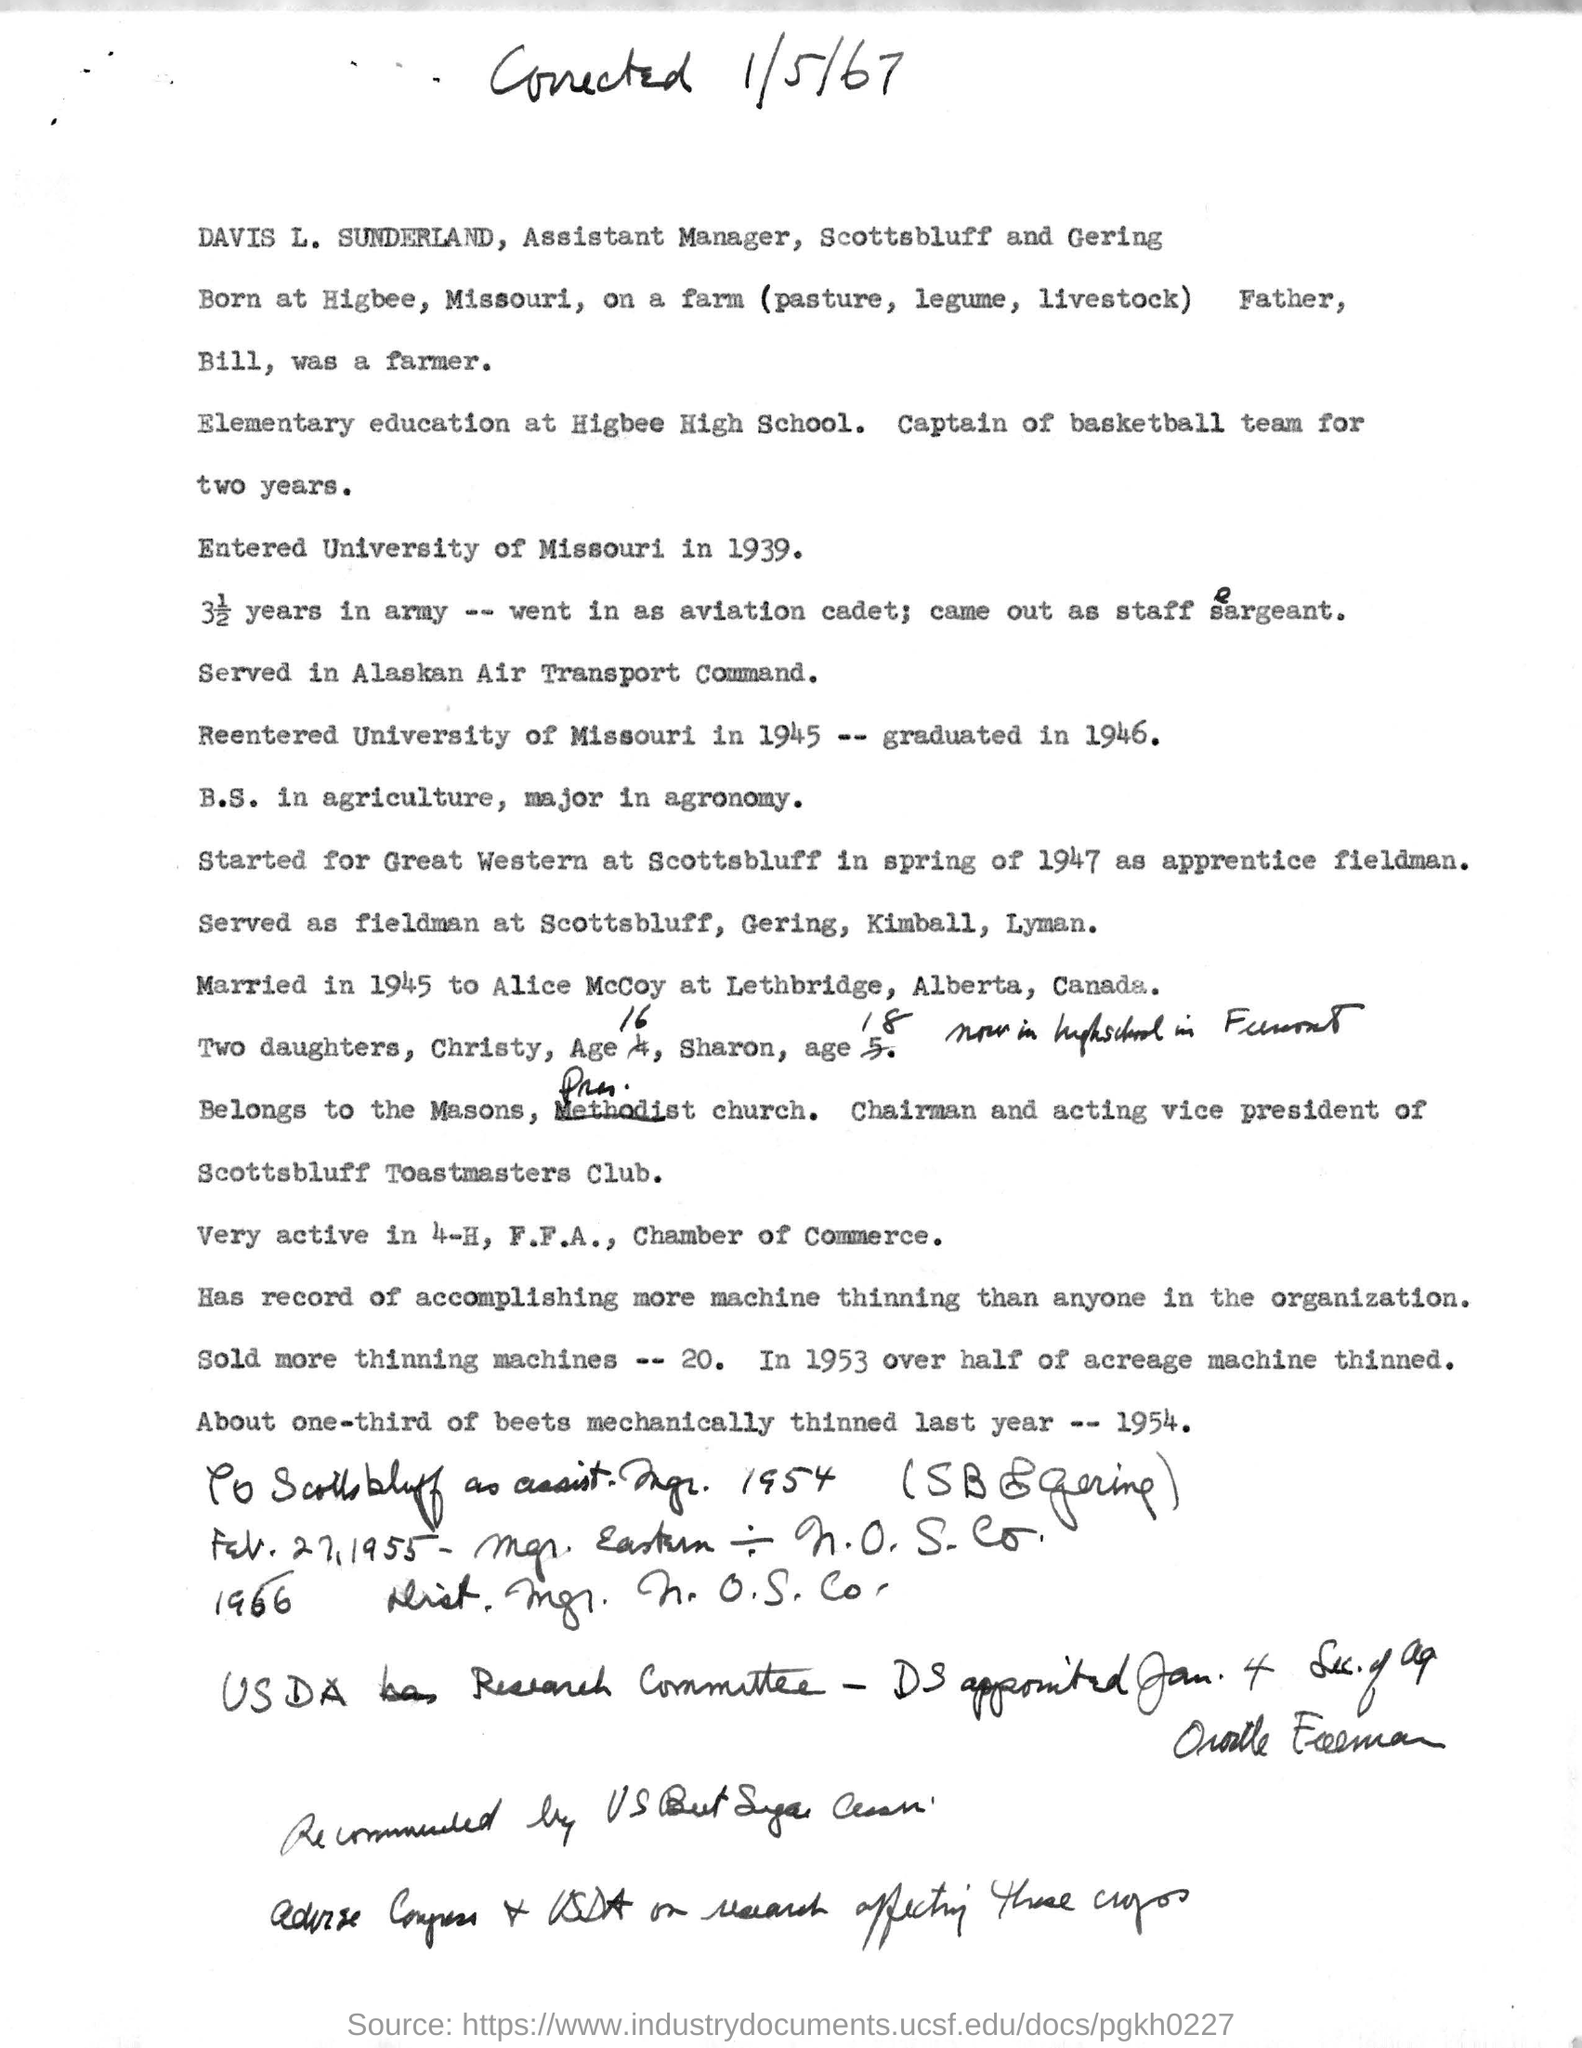Outline some significant characteristics in this image. Davis L. Sunderland holds the designation of Assistant Manager for Scottsbluff and Gering. 